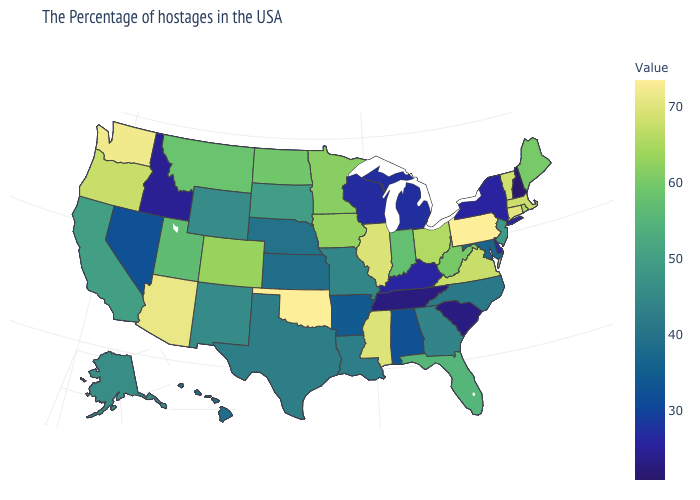Which states have the highest value in the USA?
Quick response, please. Pennsylvania, Oklahoma. Is the legend a continuous bar?
Give a very brief answer. Yes. Is the legend a continuous bar?
Write a very short answer. Yes. Does New Hampshire have the lowest value in the USA?
Keep it brief. Yes. 